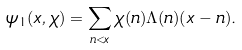<formula> <loc_0><loc_0><loc_500><loc_500>\psi _ { 1 } ( x , \chi ) = \sum _ { n < x } \chi ( n ) \Lambda ( n ) ( x - n ) .</formula> 